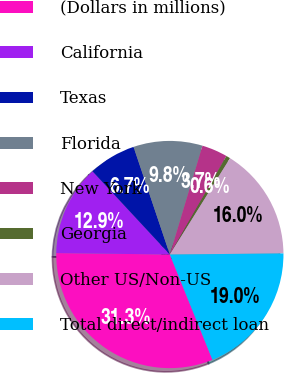Convert chart. <chart><loc_0><loc_0><loc_500><loc_500><pie_chart><fcel>(Dollars in millions)<fcel>California<fcel>Texas<fcel>Florida<fcel>New York<fcel>Georgia<fcel>Other US/Non-US<fcel>Total direct/indirect loan<nl><fcel>31.32%<fcel>12.88%<fcel>6.74%<fcel>9.81%<fcel>3.66%<fcel>0.59%<fcel>15.96%<fcel>19.03%<nl></chart> 